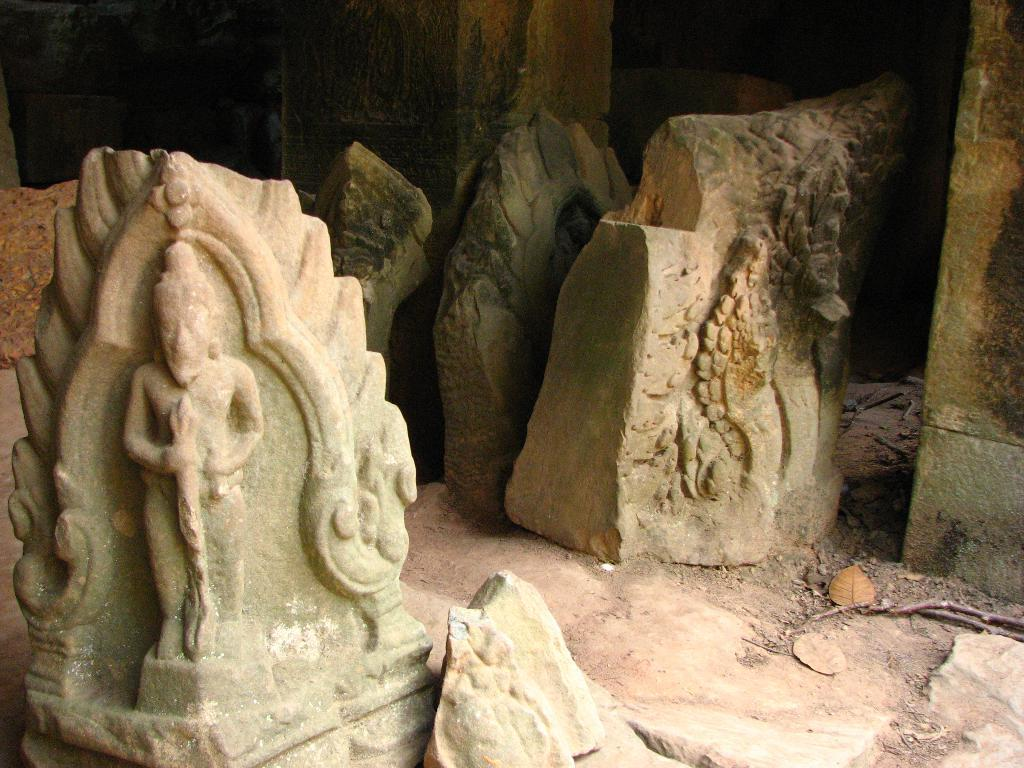What is on the stone in the image? There are artifacts on the stone in the image. What can be seen on the surface in the image? There are pillars on the surface in the image. Can you see a tree growing on the stone in the image? There is no tree growing on the top of the image; it only features a stone with artifacts and a surface with pillars. 